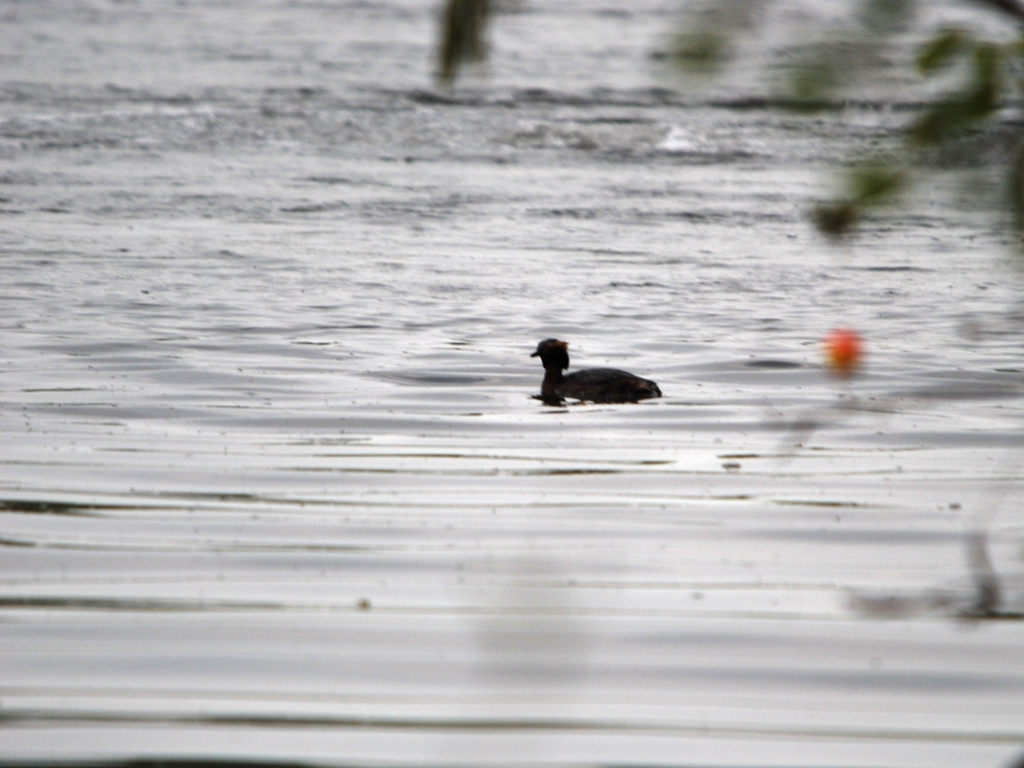Can you describe the main subject of the image? The main subject appears to be a bird floating or swimming in the water. Due to the blurriness of the image, it's difficult to identify the species with certainty. However, the bird has a dark plumage and a notable beak, which might suggest that it's a type of waterfowl or diving bird. Is there any specific detail that stands out in the image? Despite the low quality of the image, one detail that stands out is the pattern created by ripples in the water. The ripples around the bird indicate movement and add a dynamic quality to the otherwise still setting. 